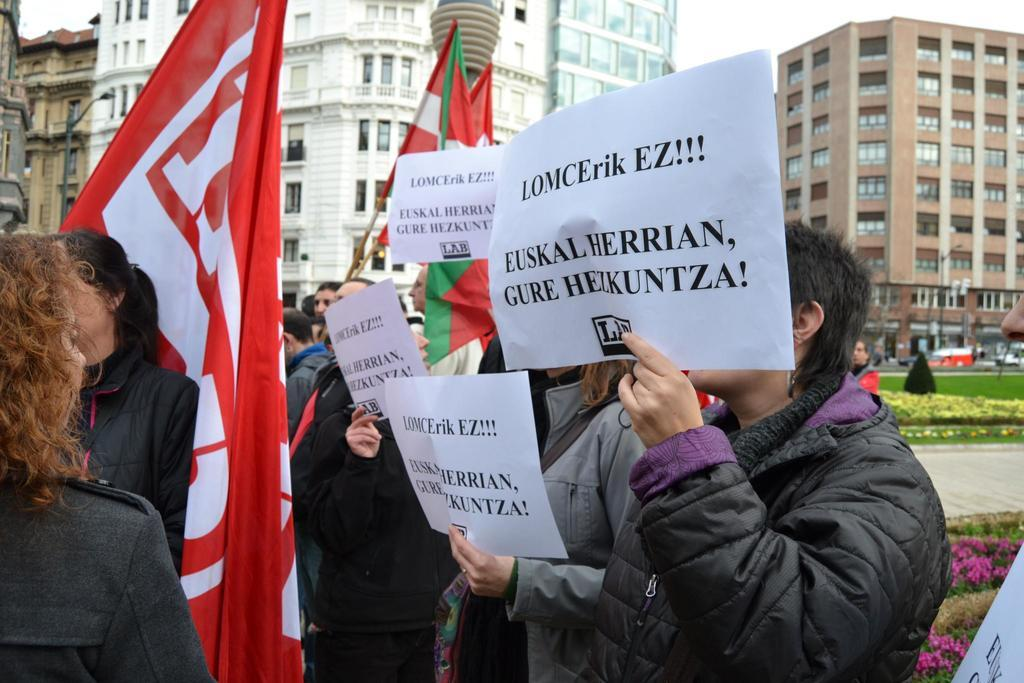How many people are in the image? There is a group of people in the image, but the exact number is not specified. What are some people holding in the image? Some people are holding papers and flags in the image. What can be seen in the background of the image? There are buildings, poles, flowers, grass, and vehicles in the background of the image. What type of jam is being spread on the list in the image? There is no jam or list present in the image. What type of gun is being used by the person in the image? There is no gun or person with a gun present in the image. 